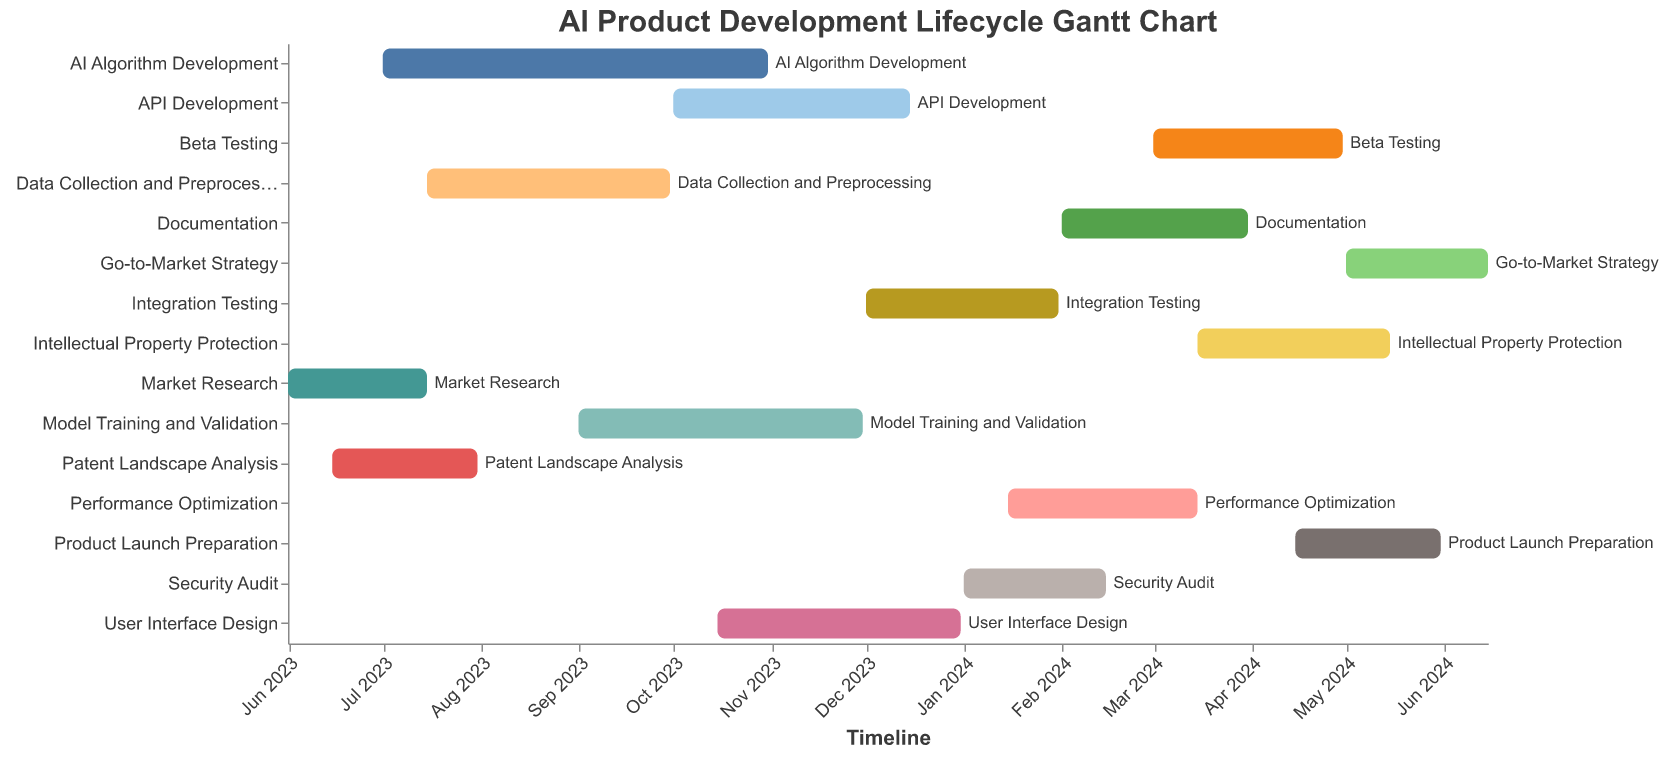What is the title of the Gantt Chart? The title of the Gantt Chart is displayed at the top of the chart. It reads "AI Product Development Lifecycle Gantt Chart."
Answer: AI Product Development Lifecycle Gantt Chart When does the "AI Algorithm Development" task start and end? The "AI Algorithm Development" task starts on 2023-07-01 and ends on 2023-10-31, as shown in the task bar within the chart.
Answer: 2023-07-01 to 2023-10-31 Which task is dependent on both "Model Training and Validation" and "API Development"? The "Integration Testing" task is dependent on both "Model Training and Validation" and "API Development," as indicated by the dependencies listed for "Integration Testing."
Answer: Integration Testing How long is the "User Interface Design" task? The "User Interface Design" task starts on 2023-10-15 and ends on 2023-12-31. To find the duration, calculate the difference between the start and end dates: from October 15, 2023, to December 31, 2023, which is 2.5 months.
Answer: 2.5 months Which task starts earliest, and which task ends last? The "Market Research" task starts earliest on 2023-06-01, and the "Go-to-Market Strategy" task ends last on 2024-06-15, as indicated by the start and end dates in the chart.
Answer: Market Research starts earliest, Go-to-Market Strategy ends last What is the duration difference between "Model Training and Validation" and "Security Audit"? "Model Training and Validation" runs from 2023-09-01 to 2023-11-30 (3 months), and "Security Audit" runs from 2024-01-01 to 2024-02-15 (1.5 months). The duration difference is 3 months - 1.5 months = 1.5 months.
Answer: 1.5 months Which tasks have their dependencies directly or indirectly linked to "Market Research"? Tasks that depend on "Market Research" directly or indirectly are "AI Algorithm Development," "Data Collection and Preprocessing," "User Interface Design," "Model Training and Validation," "Integration Testing," "Security Audit," "Performance Optimization," "Documentation," "Beta Testing," "Intellectual Property Protection," "Product Launch Preparation," and "Go-to-Market Strategy."
Answer: 12 tasks Identify two tasks that run concurrently and have overlapping durations. "AI Algorithm Development" (2023-07-01 to 2023-10-31) and "Data Collection and Preprocessing" (2023-07-15 to 2023-09-30) overlap from July 15, 2023, to September 30, 2023.
Answer: AI Algorithm Development and Data Collection and Preprocessing Which task has the maximum number of dependencies, and what are they? "Integration Testing" has the maximum number of dependencies, which are "Model Training and Validation," "API Development," and "User Interface Design."
Answer: Integration Testing (3 dependencies) By when should the "Patent Landscape Analysis" task be completed? The "Patent Landscape Analysis" task must be completed by 2023-07-31 according to the end date displayed in the chart.
Answer: 2023-07-31 